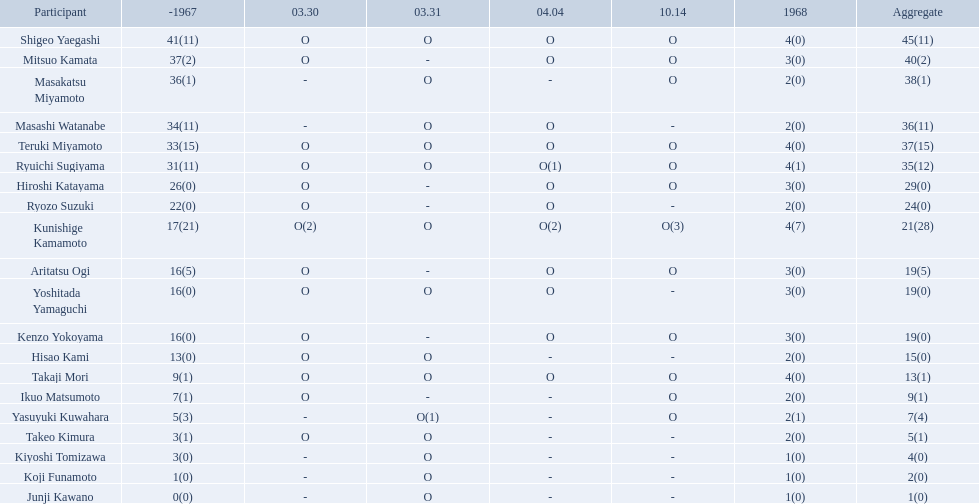How many points did takaji mori have? 13(1). And how many points did junji kawano have? 1(0). To who does the higher of these belong to? Takaji Mori. 